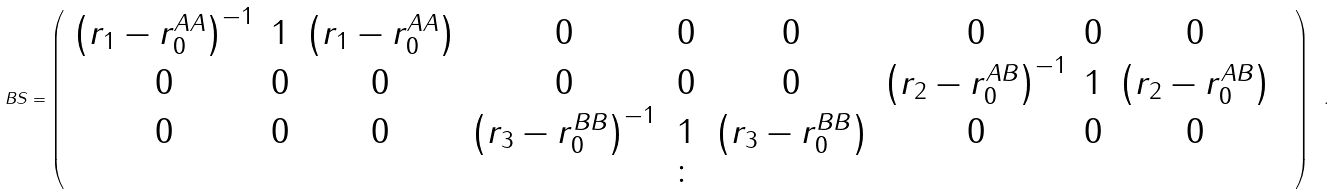Convert formula to latex. <formula><loc_0><loc_0><loc_500><loc_500>\ B S = { \left ( \begin{array} { c c c c c c c c c c } \left ( r _ { 1 } - r _ { 0 } ^ { A A } \right ) ^ { - 1 } & 1 & \left ( r _ { 1 } - r _ { 0 } ^ { A A } \right ) & 0 & 0 & 0 & 0 & 0 & 0 & \\ 0 & 0 & 0 & 0 & 0 & 0 & \left ( r _ { 2 } - r _ { 0 } ^ { A B } \right ) ^ { - 1 } & 1 & \left ( r _ { 2 } - r _ { 0 } ^ { A B } \right ) & \\ 0 & 0 & 0 & \left ( r _ { 3 } - r _ { 0 } ^ { B B } \right ) ^ { - 1 } & 1 & \left ( r _ { 3 } - r _ { 0 } ^ { B B } \right ) & 0 & 0 & 0 & \\ & & & & \colon & & & & & \\ \end{array} \right ) \ . }</formula> 